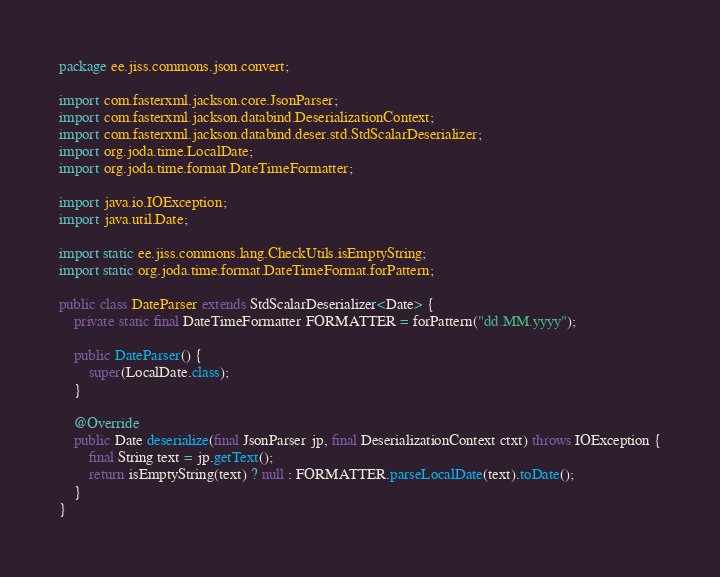<code> <loc_0><loc_0><loc_500><loc_500><_Java_>package ee.jiss.commons.json.convert;

import com.fasterxml.jackson.core.JsonParser;
import com.fasterxml.jackson.databind.DeserializationContext;
import com.fasterxml.jackson.databind.deser.std.StdScalarDeserializer;
import org.joda.time.LocalDate;
import org.joda.time.format.DateTimeFormatter;

import java.io.IOException;
import java.util.Date;

import static ee.jiss.commons.lang.CheckUtils.isEmptyString;
import static org.joda.time.format.DateTimeFormat.forPattern;

public class DateParser extends StdScalarDeserializer<Date> {
    private static final DateTimeFormatter FORMATTER = forPattern("dd.MM.yyyy");

    public DateParser() {
        super(LocalDate.class);
    }

    @Override
    public Date deserialize(final JsonParser jp, final DeserializationContext ctxt) throws IOException {
        final String text = jp.getText();
        return isEmptyString(text) ? null : FORMATTER.parseLocalDate(text).toDate();
    }
}</code> 